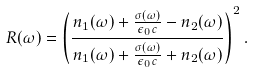<formula> <loc_0><loc_0><loc_500><loc_500>R ( \omega ) = \left ( \frac { n _ { 1 } ( \omega ) + \frac { \sigma ( \omega ) } { \epsilon _ { 0 } c } - n _ { 2 } ( \omega ) } { n _ { 1 } ( \omega ) + \frac { \sigma ( \omega ) } { \epsilon _ { 0 } c } + n _ { 2 } ( \omega ) } \right ) ^ { 2 } .</formula> 